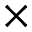<formula> <loc_0><loc_0><loc_500><loc_500>\times</formula> 